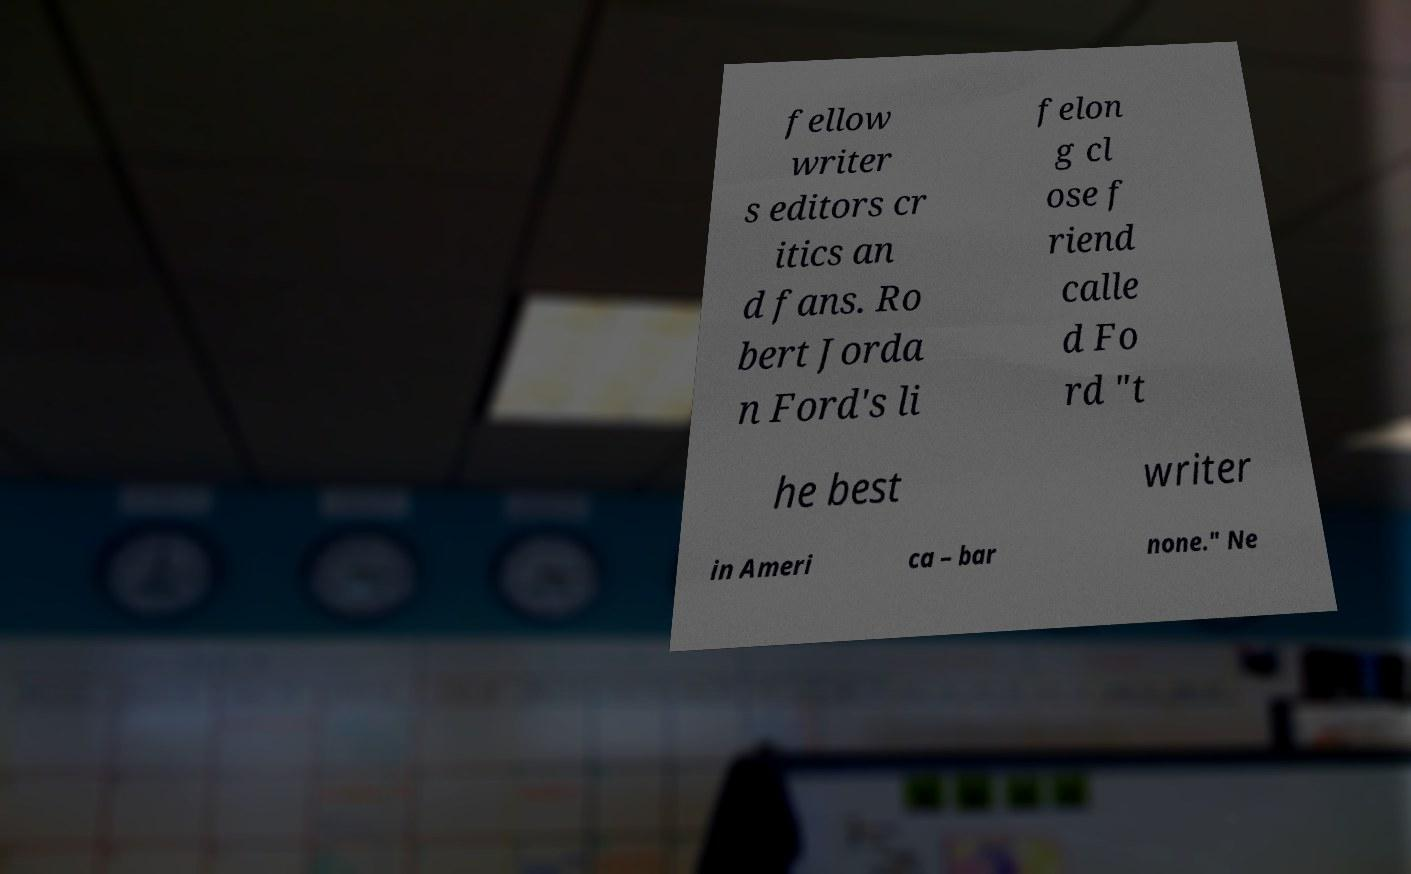Can you accurately transcribe the text from the provided image for me? fellow writer s editors cr itics an d fans. Ro bert Jorda n Ford's li felon g cl ose f riend calle d Fo rd "t he best writer in Ameri ca – bar none." Ne 